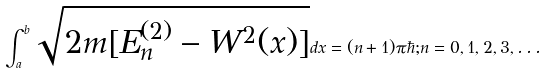Convert formula to latex. <formula><loc_0><loc_0><loc_500><loc_500>\int ^ { b } _ { a } \sqrt { 2 m [ E ^ { ( 2 ) } _ { n } - W ^ { 2 } ( x ) ] } d x = ( n + 1 ) \pi \hbar { ; } n = 0 , 1 , 2 , 3 , \dots</formula> 